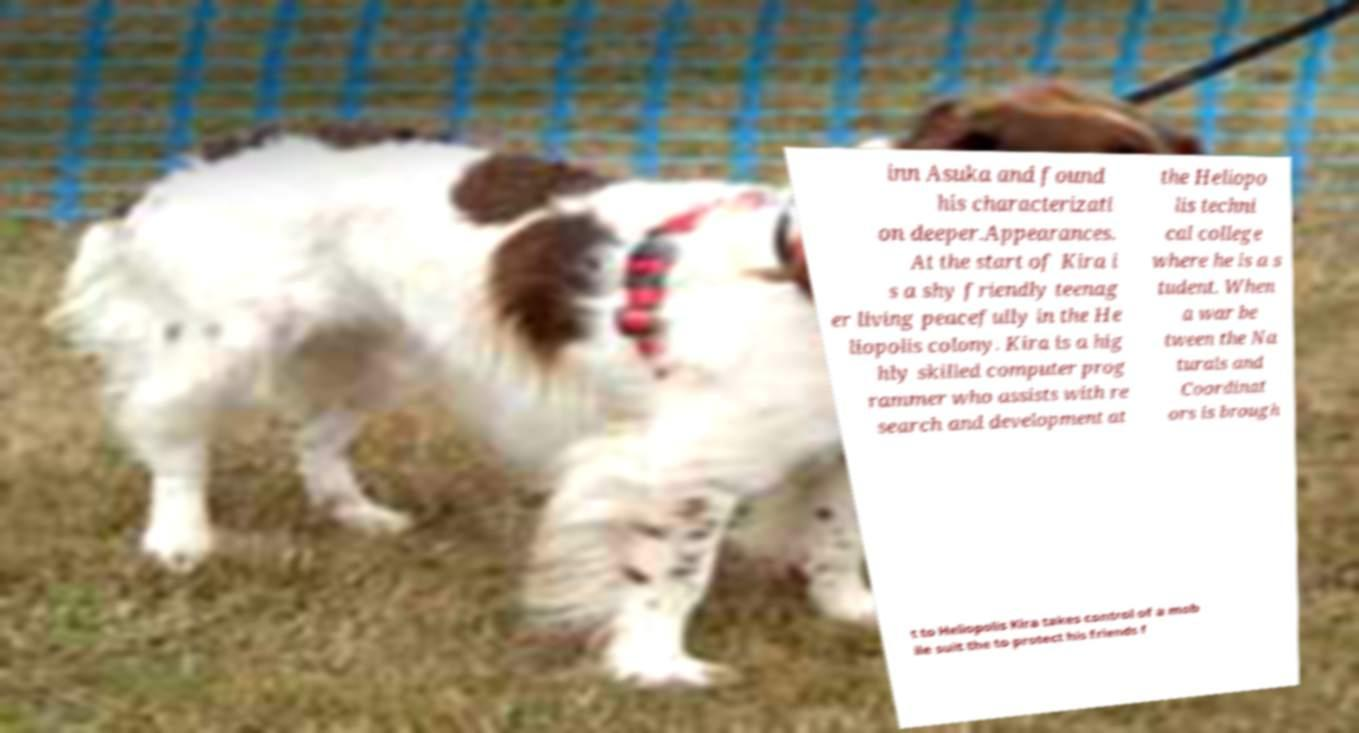Could you assist in decoding the text presented in this image and type it out clearly? inn Asuka and found his characterizati on deeper.Appearances. At the start of Kira i s a shy friendly teenag er living peacefully in the He liopolis colony. Kira is a hig hly skilled computer prog rammer who assists with re search and development at the Heliopo lis techni cal college where he is a s tudent. When a war be tween the Na turals and Coordinat ors is brough t to Heliopolis Kira takes control of a mob ile suit the to protect his friends f 